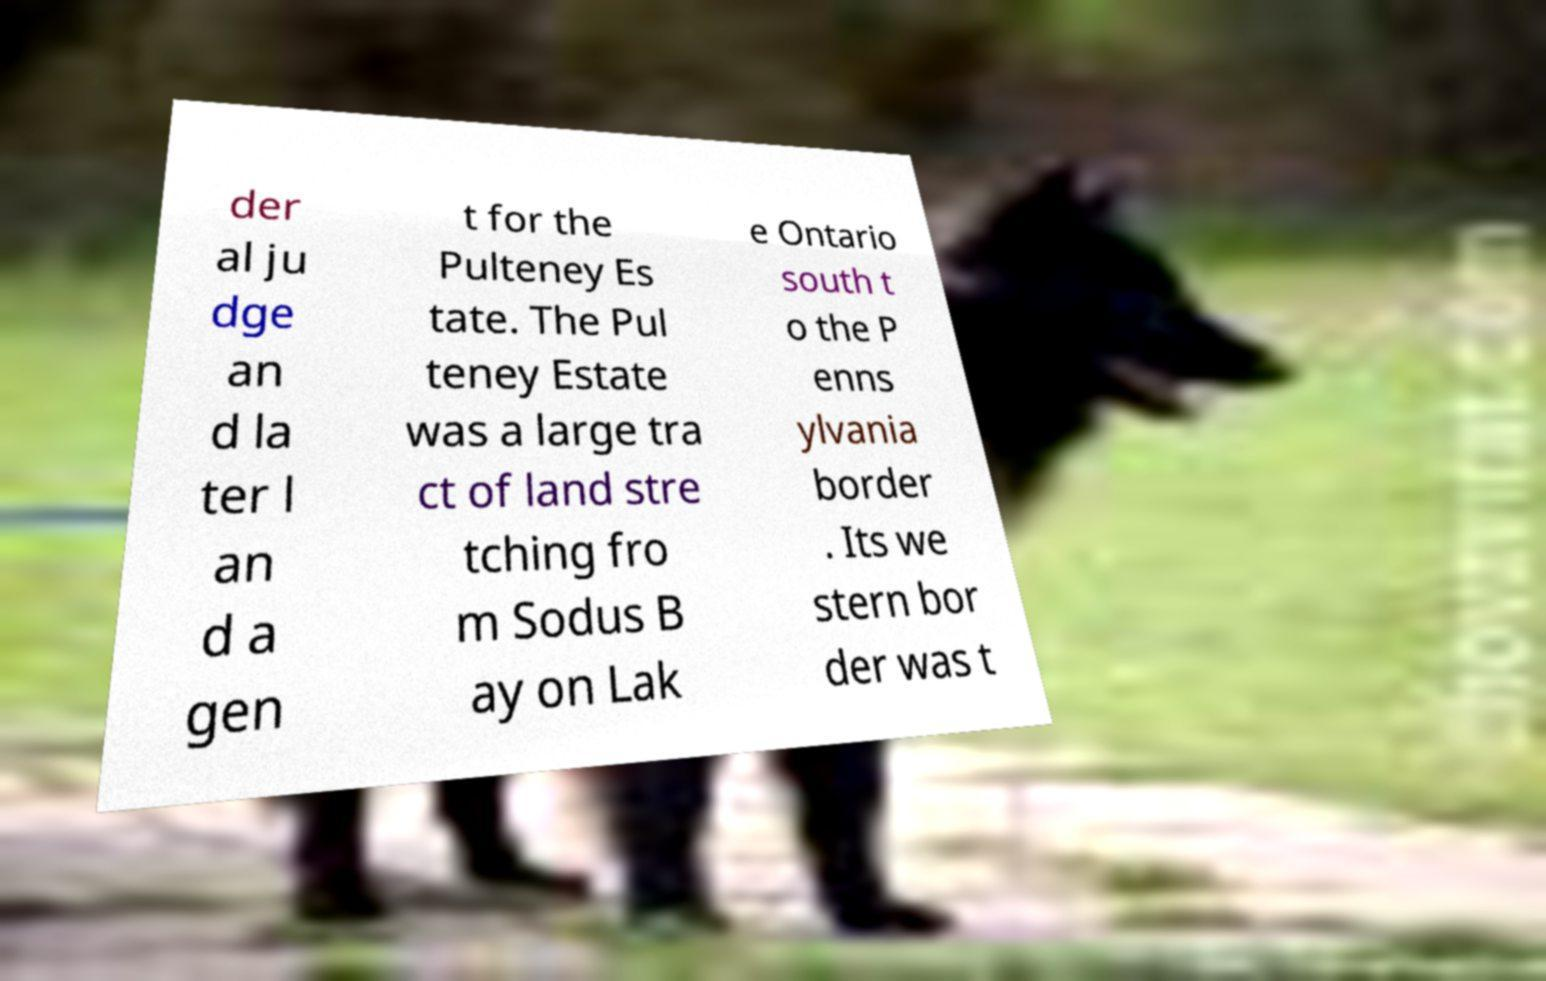Please read and relay the text visible in this image. What does it say? der al ju dge an d la ter l an d a gen t for the Pulteney Es tate. The Pul teney Estate was a large tra ct of land stre tching fro m Sodus B ay on Lak e Ontario south t o the P enns ylvania border . Its we stern bor der was t 